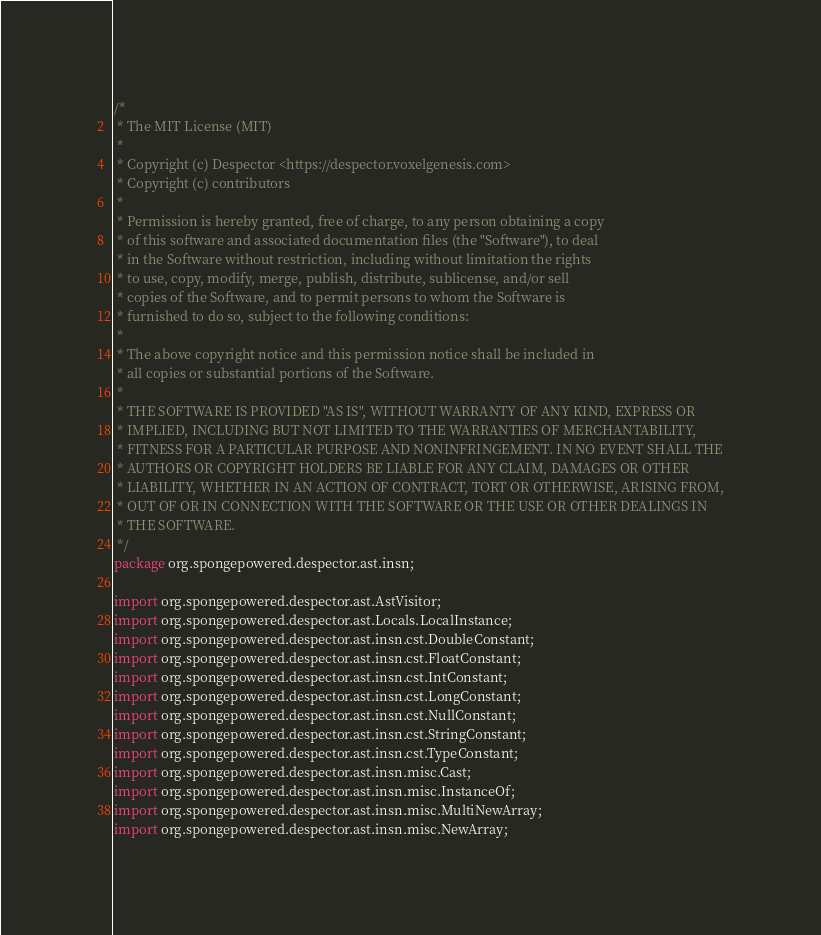<code> <loc_0><loc_0><loc_500><loc_500><_Java_>/*
 * The MIT License (MIT)
 *
 * Copyright (c) Despector <https://despector.voxelgenesis.com>
 * Copyright (c) contributors
 *
 * Permission is hereby granted, free of charge, to any person obtaining a copy
 * of this software and associated documentation files (the "Software"), to deal
 * in the Software without restriction, including without limitation the rights
 * to use, copy, modify, merge, publish, distribute, sublicense, and/or sell
 * copies of the Software, and to permit persons to whom the Software is
 * furnished to do so, subject to the following conditions:
 *
 * The above copyright notice and this permission notice shall be included in
 * all copies or substantial portions of the Software.
 *
 * THE SOFTWARE IS PROVIDED "AS IS", WITHOUT WARRANTY OF ANY KIND, EXPRESS OR
 * IMPLIED, INCLUDING BUT NOT LIMITED TO THE WARRANTIES OF MERCHANTABILITY,
 * FITNESS FOR A PARTICULAR PURPOSE AND NONINFRINGEMENT. IN NO EVENT SHALL THE
 * AUTHORS OR COPYRIGHT HOLDERS BE LIABLE FOR ANY CLAIM, DAMAGES OR OTHER
 * LIABILITY, WHETHER IN AN ACTION OF CONTRACT, TORT OR OTHERWISE, ARISING FROM,
 * OUT OF OR IN CONNECTION WITH THE SOFTWARE OR THE USE OR OTHER DEALINGS IN
 * THE SOFTWARE.
 */
package org.spongepowered.despector.ast.insn;

import org.spongepowered.despector.ast.AstVisitor;
import org.spongepowered.despector.ast.Locals.LocalInstance;
import org.spongepowered.despector.ast.insn.cst.DoubleConstant;
import org.spongepowered.despector.ast.insn.cst.FloatConstant;
import org.spongepowered.despector.ast.insn.cst.IntConstant;
import org.spongepowered.despector.ast.insn.cst.LongConstant;
import org.spongepowered.despector.ast.insn.cst.NullConstant;
import org.spongepowered.despector.ast.insn.cst.StringConstant;
import org.spongepowered.despector.ast.insn.cst.TypeConstant;
import org.spongepowered.despector.ast.insn.misc.Cast;
import org.spongepowered.despector.ast.insn.misc.InstanceOf;
import org.spongepowered.despector.ast.insn.misc.MultiNewArray;
import org.spongepowered.despector.ast.insn.misc.NewArray;</code> 